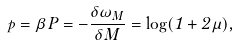Convert formula to latex. <formula><loc_0><loc_0><loc_500><loc_500>p = \beta P = - \frac { \delta \omega _ { M } } { \delta M } = \log ( 1 + 2 \mu ) ,</formula> 